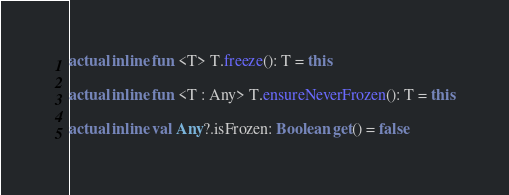<code> <loc_0><loc_0><loc_500><loc_500><_Kotlin_>actual inline fun <T> T.freeze(): T = this

actual inline fun <T : Any> T.ensureNeverFrozen(): T = this

actual inline val Any?.isFrozen: Boolean get() = false
</code> 